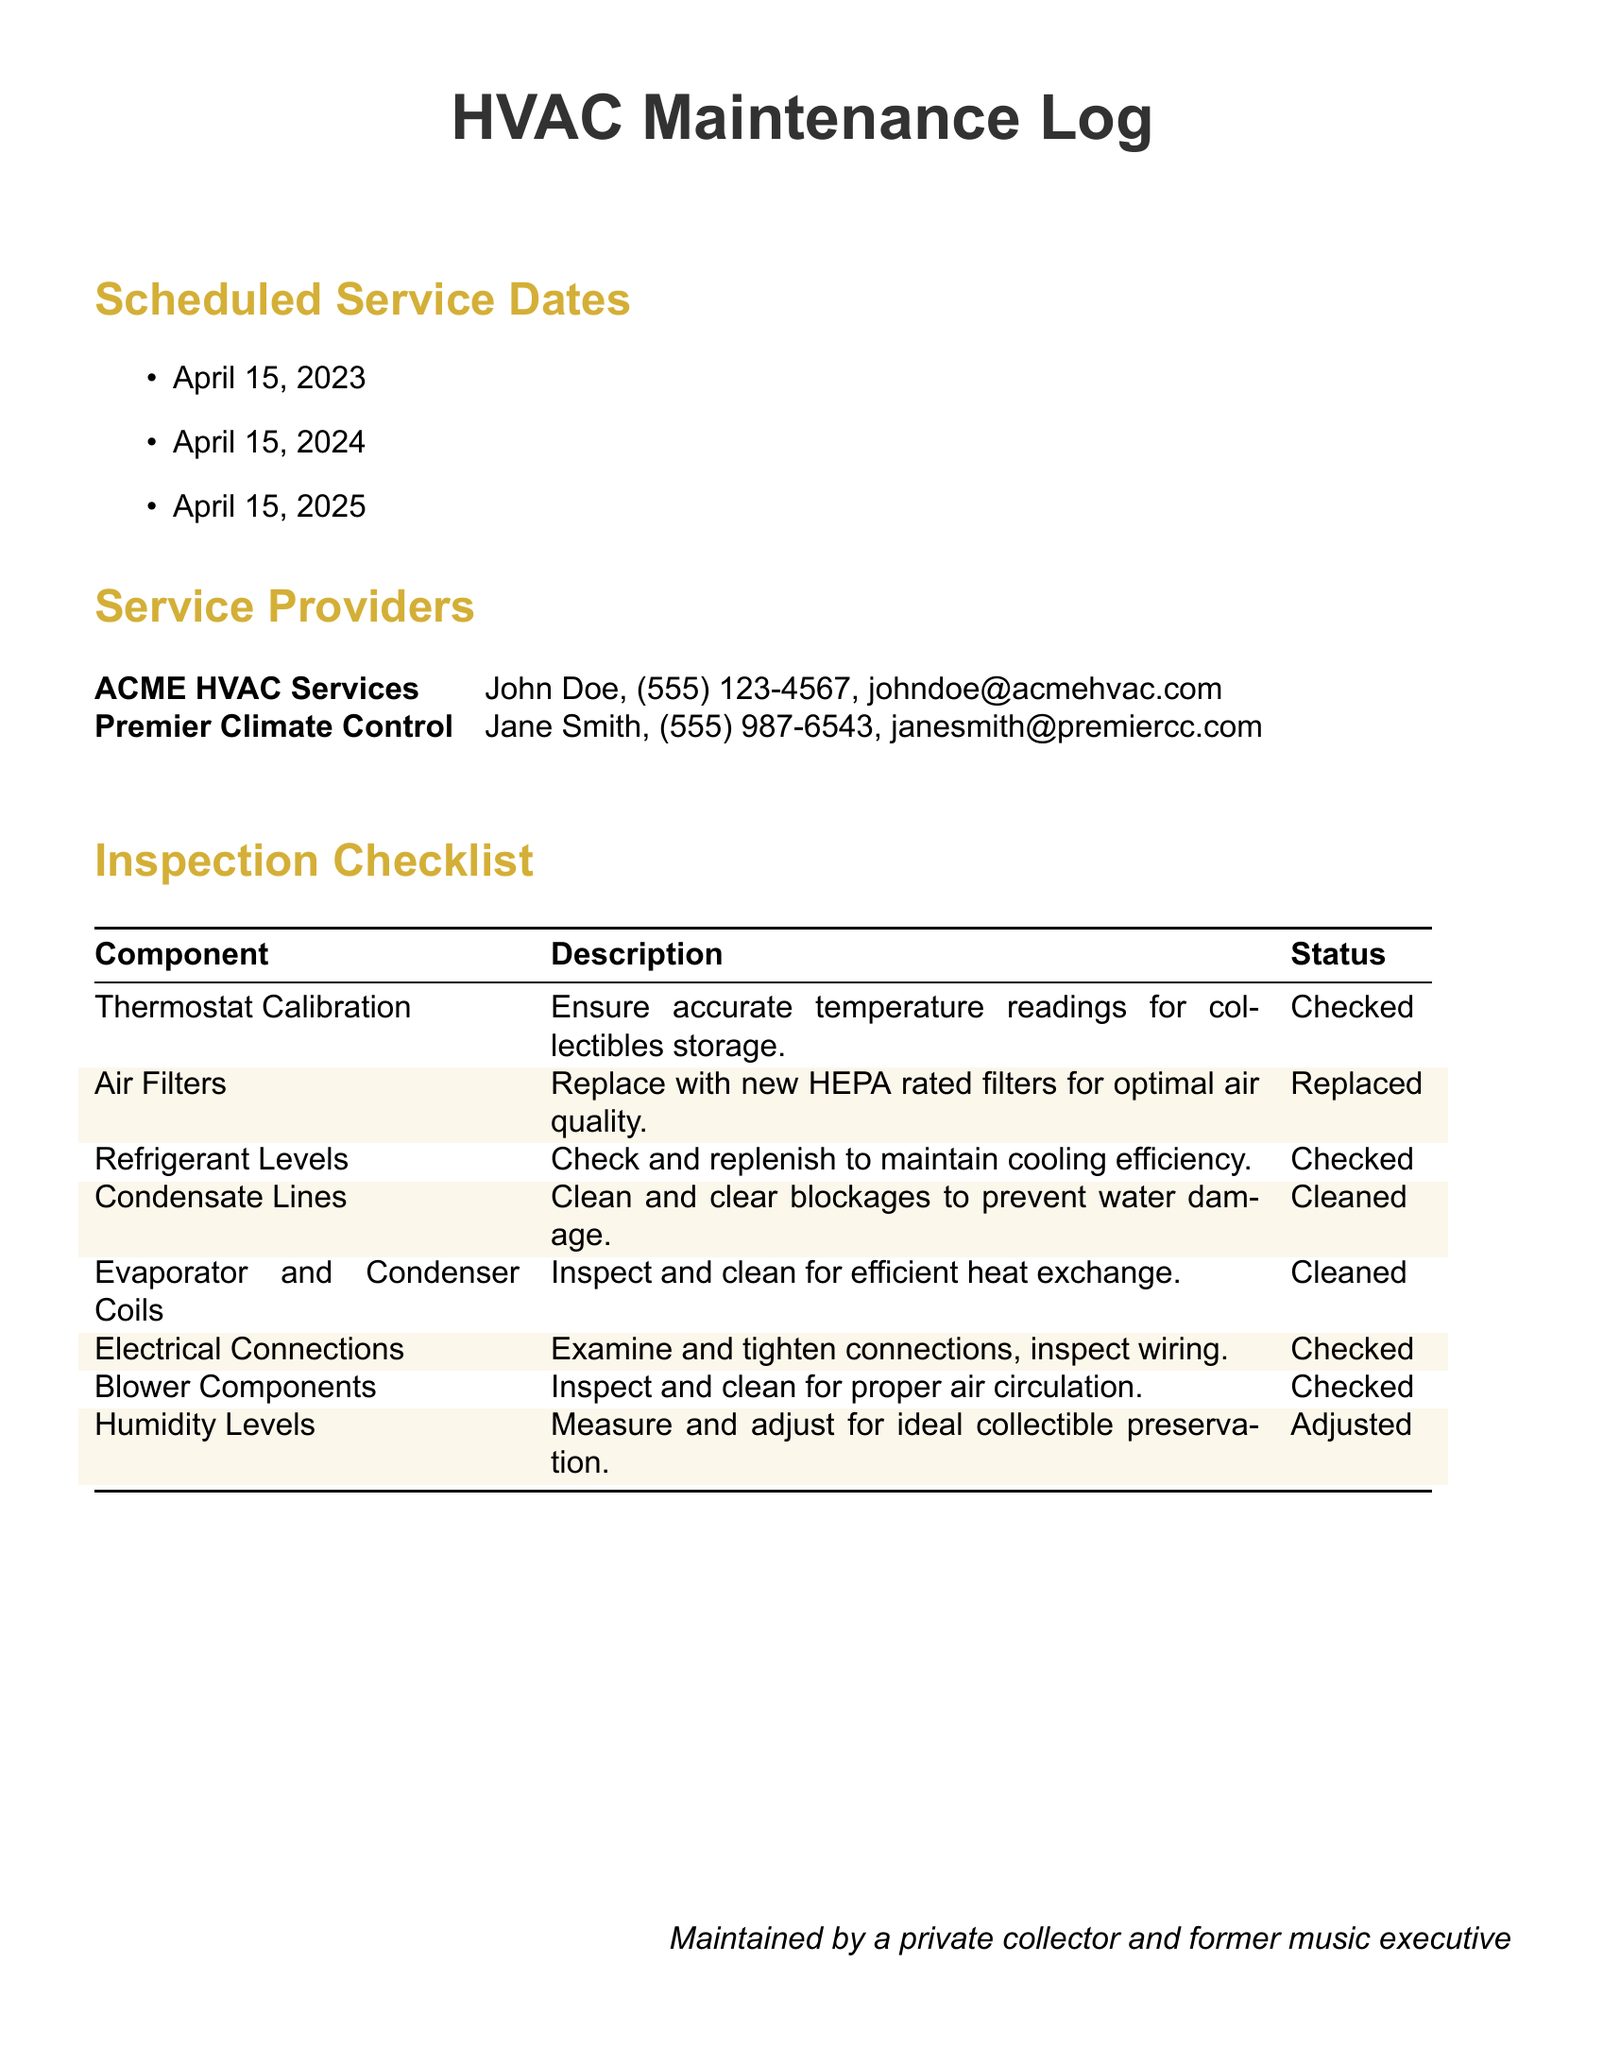what is the date of the next scheduled service? The next scheduled service is mentioned under the Scheduled Service Dates section as April 15, 2024.
Answer: April 15, 2024 who is the contact for ACME HVAC Services? The document lists John Doe as the contact for ACME HVAC Services along with his phone number and email.
Answer: John Doe what was replaced during the April 2023 maintenance? The Inspection Checklist indicates that air filters were replaced during the maintenance.
Answer: Air Filters how many inspections are scheduled in total? The Scheduled Service Dates section lists three different dates for inspections.
Answer: Three which component was adjusted for ideal collectible preservation? The Inspection Checklist specifies that humidity levels were adjusted for collectible preservation.
Answer: Humidity Levels who performed the HVAC maintenance in April 2023? The document does not specify which service provider was responsible for the April 2023 maintenance but lists both providers.
Answer: Not specified what component was cleaned to prevent water damage? The Inspection Checklist states that condensate lines were cleaned to prevent water damage.
Answer: Condensate Lines which component requires checking and replenishing of refrigerant levels? The document explicitly states that refrigerant levels need to be checked and replenished.
Answer: Refrigerant Levels 